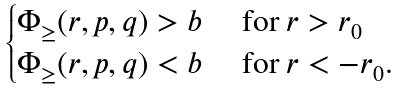Convert formula to latex. <formula><loc_0><loc_0><loc_500><loc_500>\begin{cases} \Phi _ { \geq } ( r , p , q ) > b & \text { for } r > r _ { 0 } \\ \Phi _ { \geq } ( r , p , q ) < b & \text { for } r < - r _ { 0 } . \end{cases}</formula> 